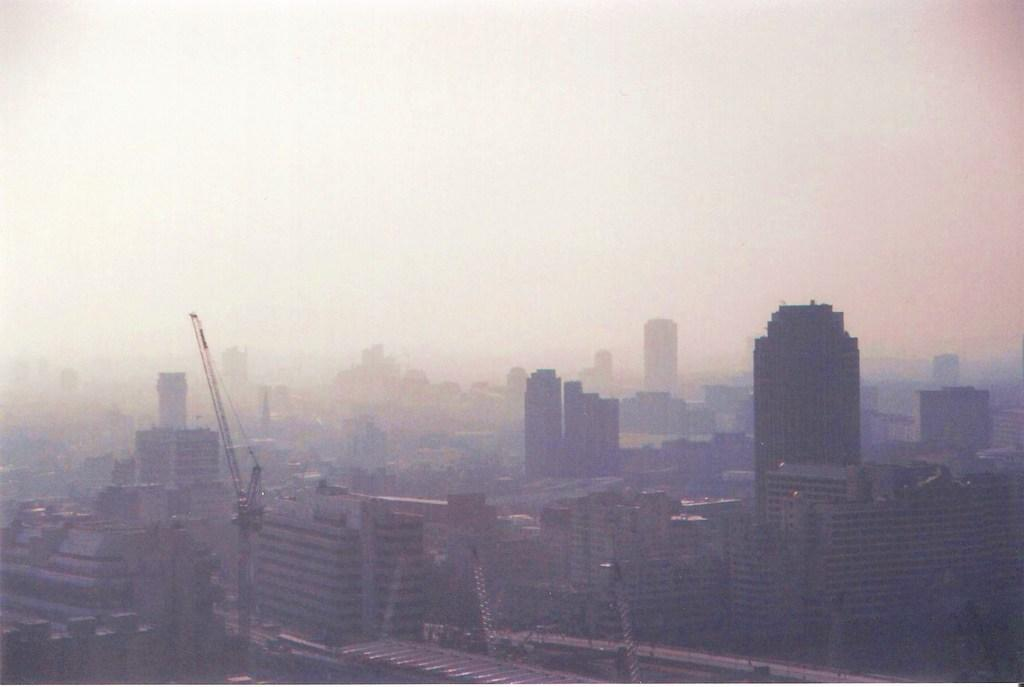What type of structures can be seen in the image? There are many buildings in the image. Are there any construction-related elements visible in the image? Yes, there are tower cranes in the image. What type of coal is being transported by the minister in the image? There is no minister or coal present in the image; it only features buildings and tower cranes. 